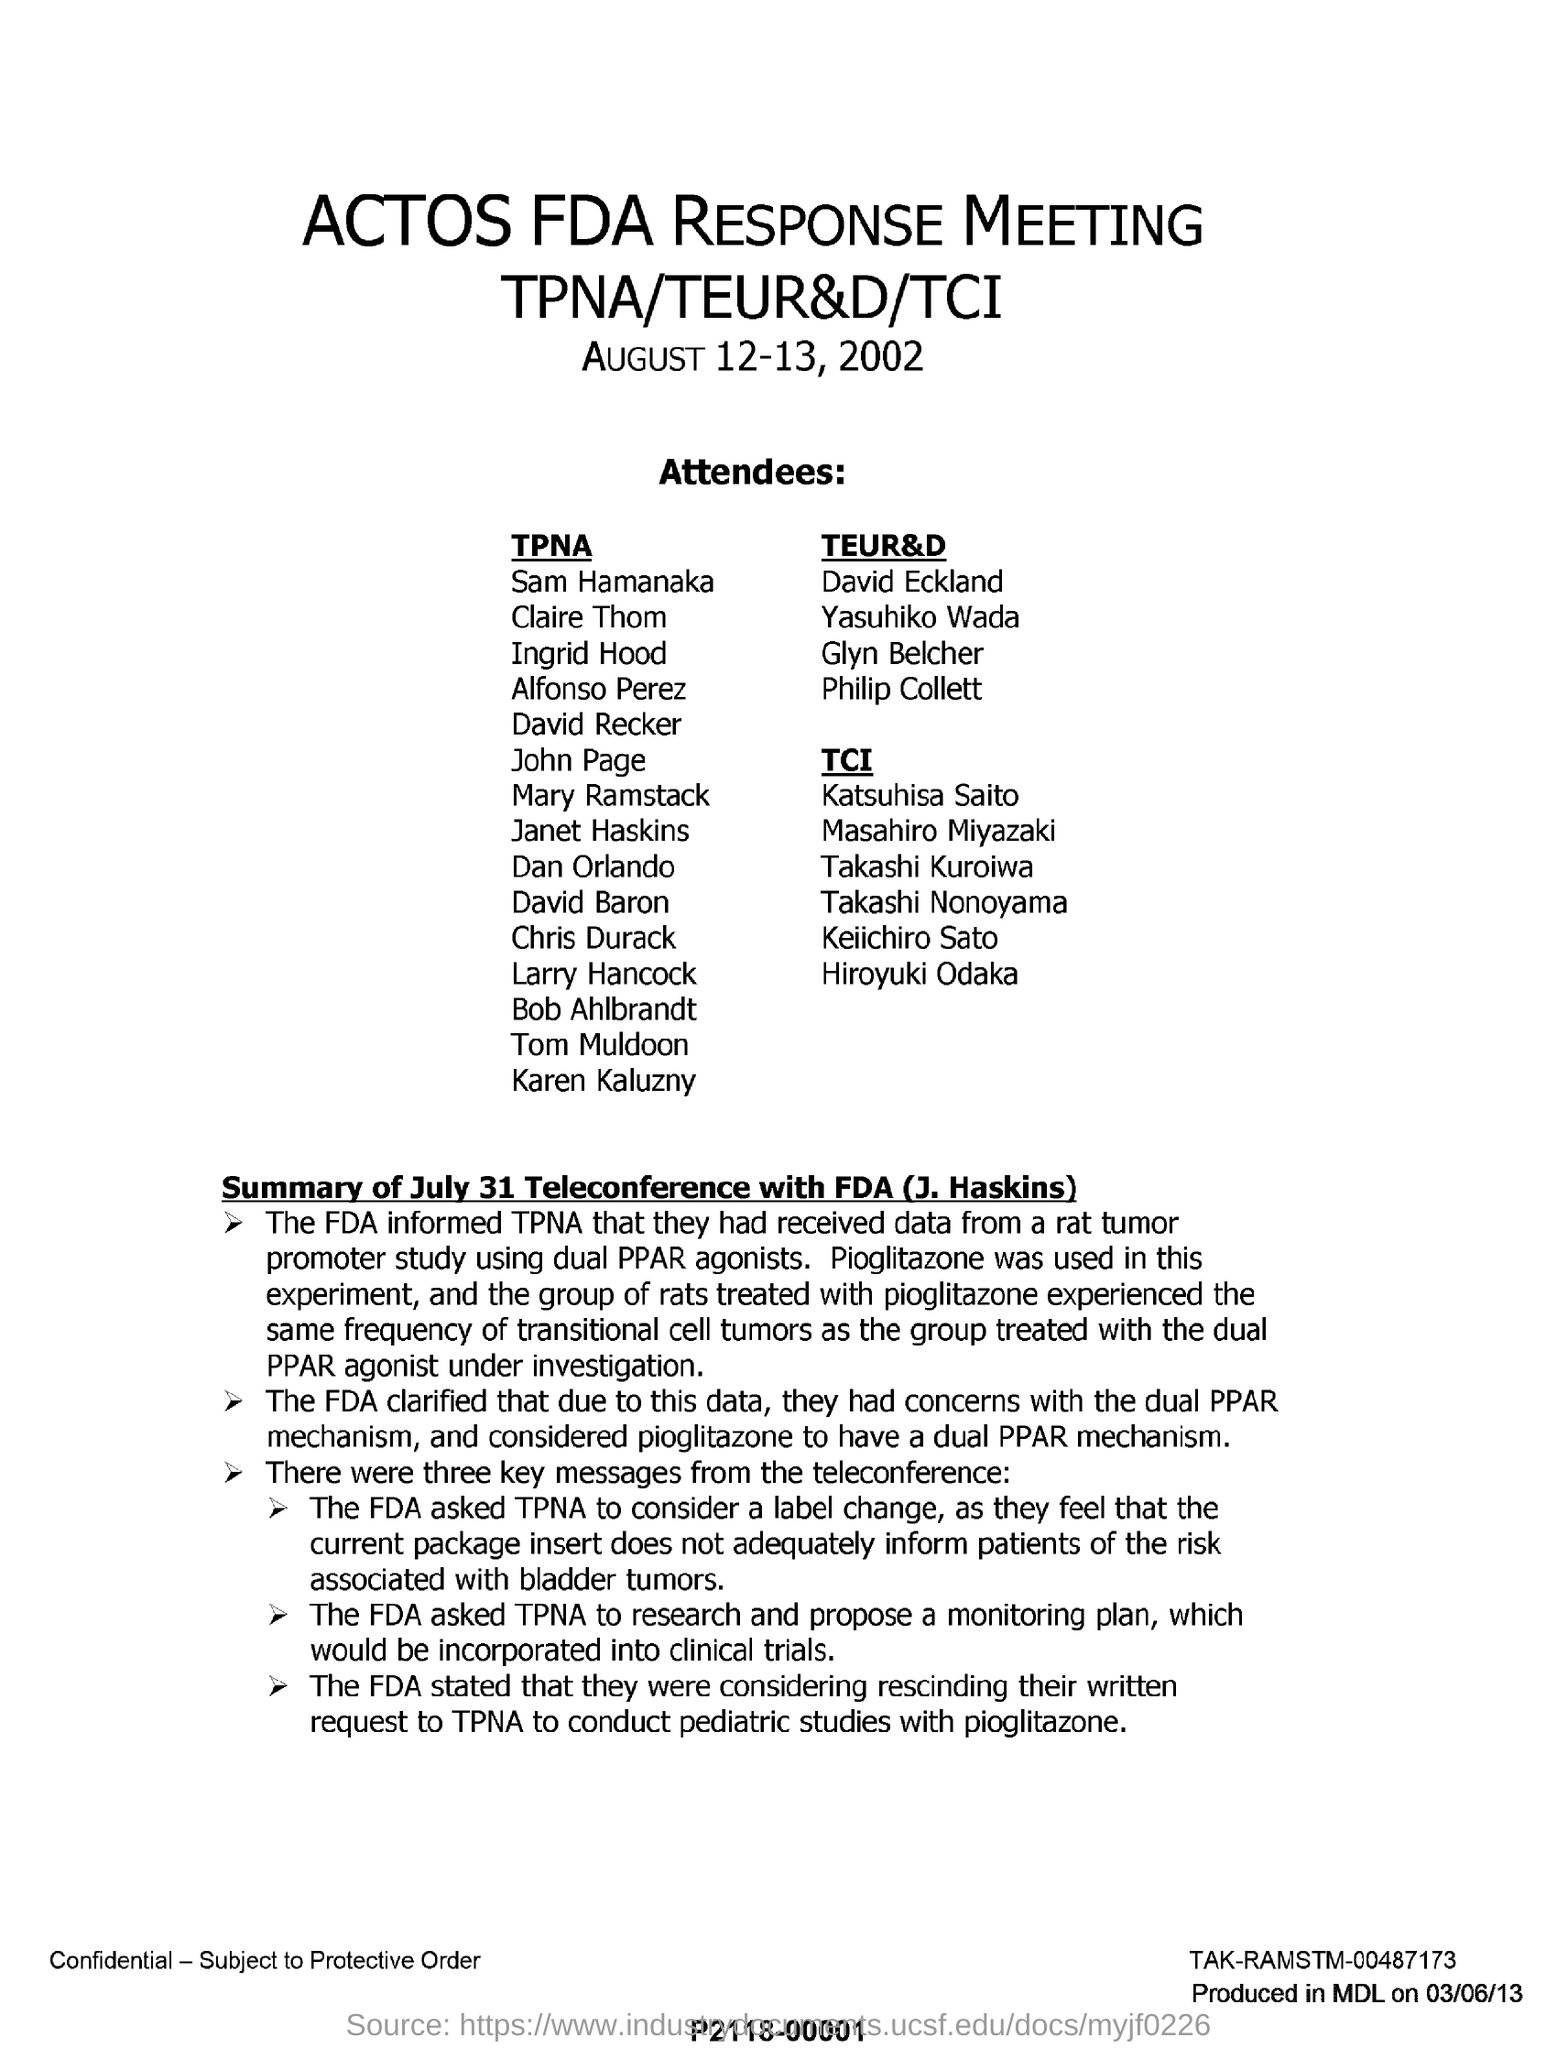What kind of meeting is mentioned in this letter?
Offer a terse response. ACTOS FDA RESPONSE MEETING. What kind of drug is used to treat the group of rats?
Ensure brevity in your answer.  Pioglitazone. What kind of cell tumours experienced the same frequency when group of rats treated with pioglitazone?
Your response must be concise. Transitional cell tumors. 